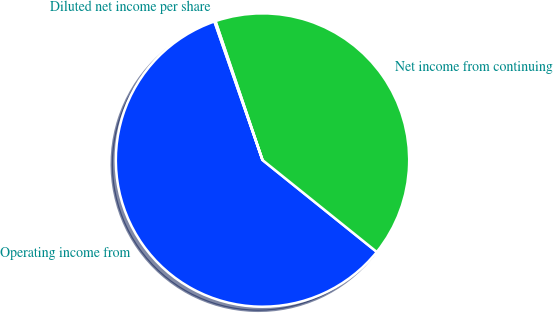<chart> <loc_0><loc_0><loc_500><loc_500><pie_chart><fcel>Operating income from<fcel>Net income from continuing<fcel>Diluted net income per share<nl><fcel>58.91%<fcel>40.98%<fcel>0.12%<nl></chart> 